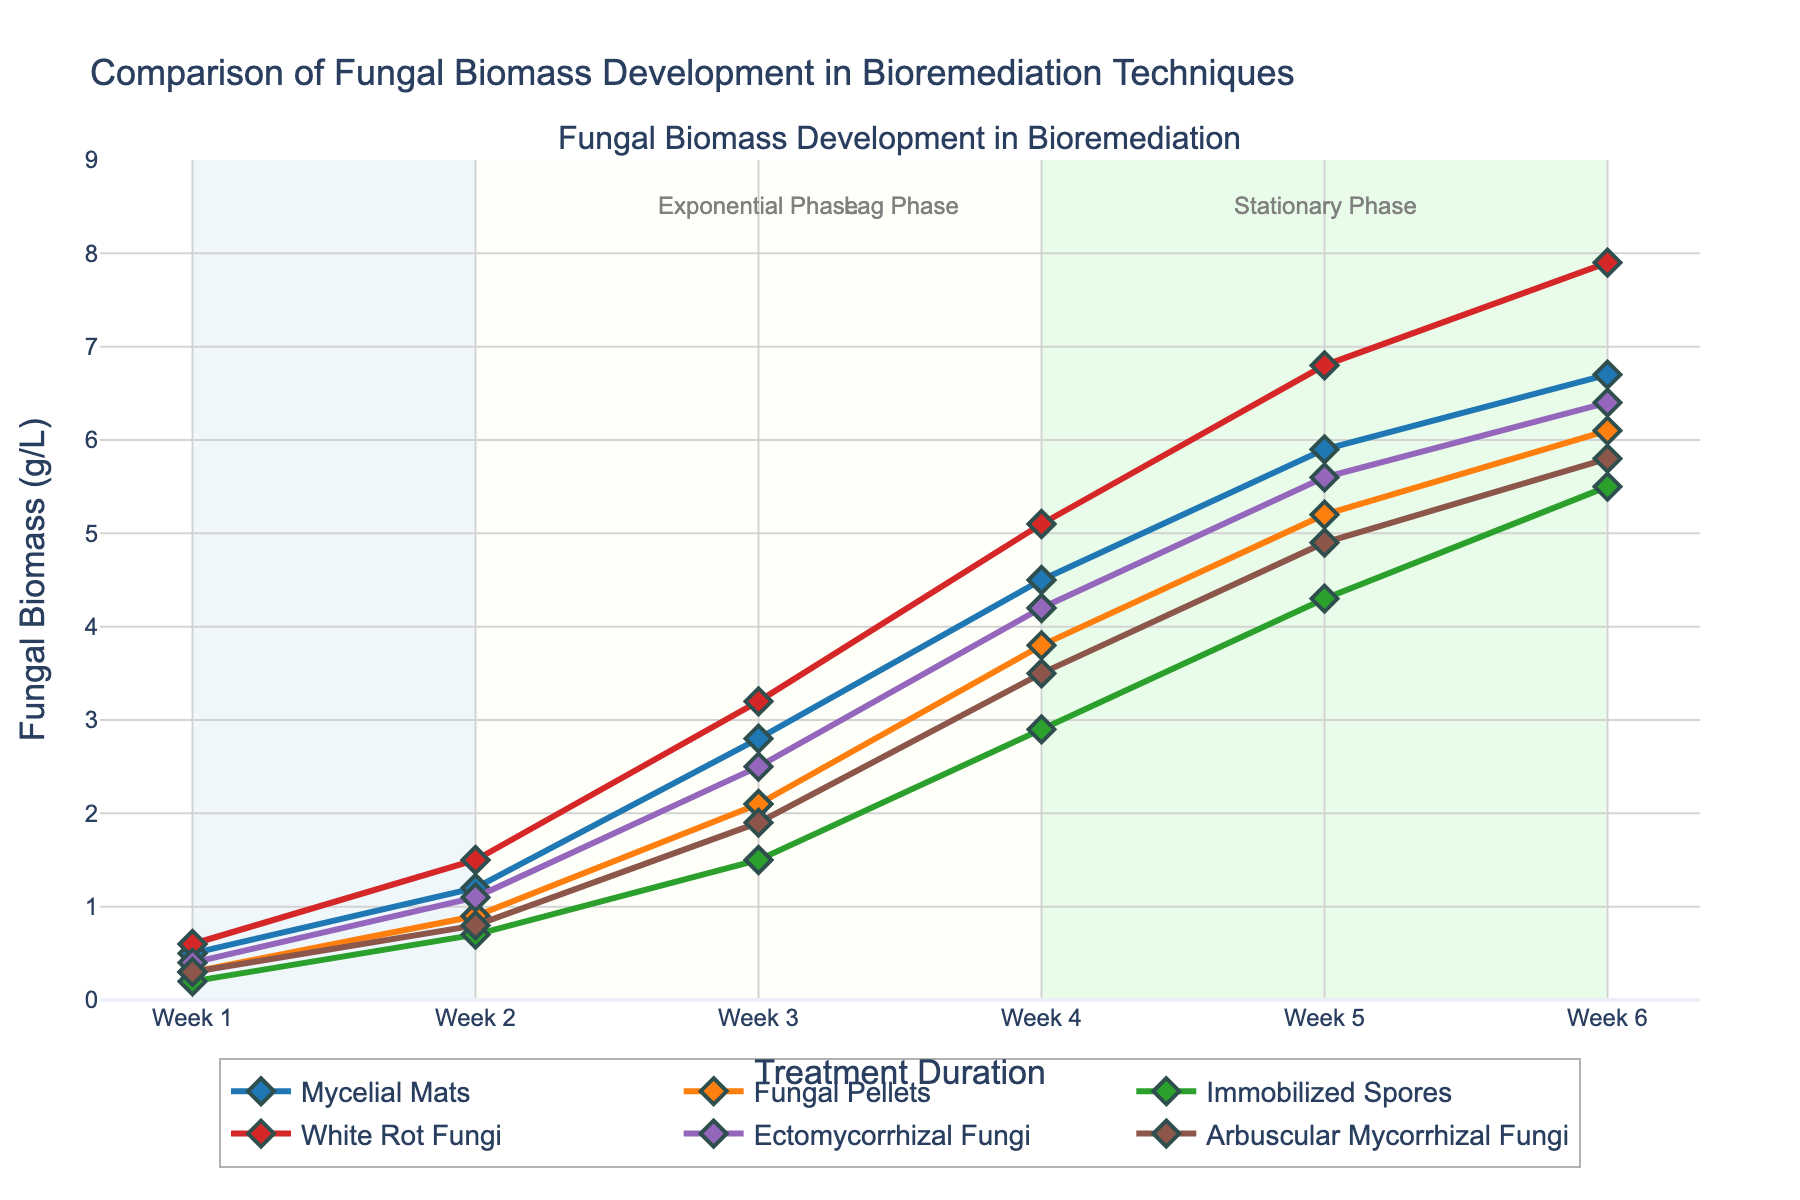Which technique exhibits the highest biomass development by Week 6? By examining the biomass values for all techniques at Week 6, White Rot Fungi show the highest value at 7.9 g/L.
Answer: White Rot Fungi How much total biomass did Mycelial Mats and Fungal Pellets develop over the 6 weeks? First, find the biomass values for Mycelial Mats (0.5, 1.2, 2.8, 4.5, 5.9, 6.7) and Fungal Pellets (0.3, 0.9, 2.1, 3.8, 5.2, 6.1). Then sum them both separately: Mycelial Mats = 21.6 g/L, Fungal Pellets = 18.4 g/L. Combining them results in 21.6 + 18.4 = 40.0 g/L.
Answer: 40.0 g/L Which two fungal techniques have the closest biomass values at Week 2? Compare the biomass values of each technique at Week 2: Mycelial Mats (1.2), Fungal Pellets (0.9), Immobilized Spores (0.7), White Rot Fungi (1.5), Ectomycorrhizal Fungi (1.1), and Arbuscular Mycorrhizal Fungi (0.8). Ectomycorrhizal Fungi (1.1) and Mycelial Mats (1.2) are the closest.
Answer: Ectomycorrhizal Fungi and Mycelial Mats Which growth phase shows the most significant difference in biomass for White Rot Fungi between Week 1 and Week 4? Looking at the growth phases: From Week 1 to Week 2 and Week 2 to Week 4. Biomass difference between Week 1 and Week 2 is 1.5 - 0.6 = 0.9, between Week 2 and Week 4 is 5.1 - 1.5 = 3.6. Therefore, the biggest difference in biomass occurs between Week 2 and Week 4.
Answer: Between Week 2 and Week 4 What is the average weekly growth for Arbuscular Mycorrhizal Fungi? Sum the weekly biomass values for Arbuscular Mycorrhizal Fungi (0.3, 0.8, 1.9, 3.5, 4.9, 5.8) = 17.2. Divide by the number of weeks, 17.2 / 6 = approximately 2.87 g/L.
Answer: 2.87 g/L How does the growth trend of Fungal Pellets compare to Mycelial Mats? Both techniques show a consistent increase in biomass. However, Mycelial Mats consistently surpass Fungal Pellets each week, starting from a higher initial value and maintaining a steeper upward trend throughout the time period.
Answer: Mycelial Mats grow faster At Week 3, which technique is closer to their maximum biomass? First, identify maximum biomasses: Mycelial Mats (6.7), Fungal Pellets (6.1), Immobilized Spores (5.5), White Rot Fungi (7.9), Ectomycorrhizal Fungi (6.4), Arbuscular Mycorrhizal Fungi (5.8). Compare these to Week 3 values and calculate proximity: White Rot Fungi at Week 3 is 3.2; it is further from its max than Ectomycorrhizal Fungi at 2.5 to 6.4. Hence, Arbuscular Mycorrhizal Fungi at 3.5 to 5.8 (61% closer) is ultimately closer relatively.
Answer: Arbuscular Mycorrhizal Fungi In the Exponential Growth phase (Week 2 to Week 4), which technique shows the least biomass increment? Calculate the difference from Week 2 to Week 4 for each technique: Mycelial Mats = 4.5 - 1.2 = 3.3, Fungal Pellets = 3.8 - 0.9 = 2.9, Immobilized Spores = 2.9 - 0.7 = 2.2, White Rot Fungi = 5.1 - 1.5 = 3.6, Ectomycorrhizal Fungi = 4.2 - 1.1 = 3.1, Arbuscular Mycorrhizal Fungi = 3.5 - 0.8 = 2.7. The least biomass increment happens for Immobilized Spores.
Answer: Immobilized Spores Which technique’s biomass growth pattern stands out visually due to color? The White Rot Fungi trace is visually prominent due to its vibrant red line, indicating a consistent and steep growth trend throughout the treatment duration.
Answer: White Rot Fungi 